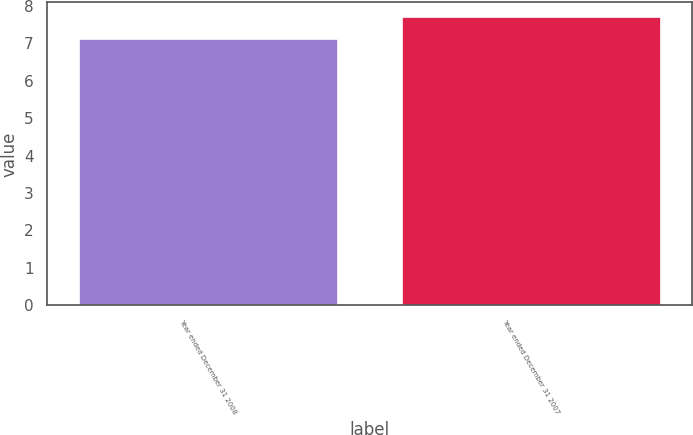Convert chart. <chart><loc_0><loc_0><loc_500><loc_500><bar_chart><fcel>Year ended December 31 2008<fcel>Year ended December 31 2007<nl><fcel>7.1<fcel>7.7<nl></chart> 